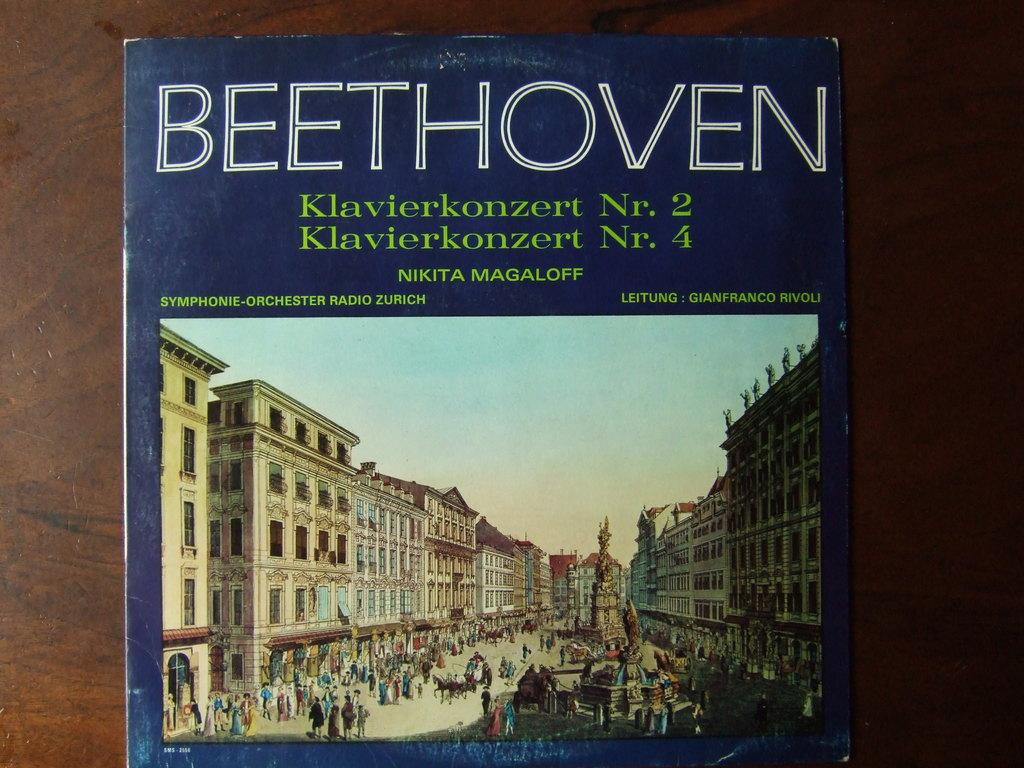<image>
Describe the image concisely. A Beethoven record featuring Klavierkonzert Nr. 2 and Nr. 4. 